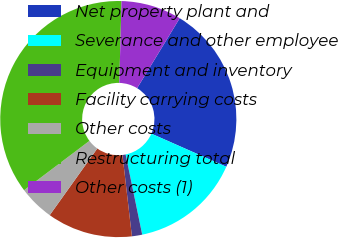<chart> <loc_0><loc_0><loc_500><loc_500><pie_chart><fcel>Net property plant and<fcel>Severance and other employee<fcel>Equipment and inventory<fcel>Facility carrying costs<fcel>Other costs<fcel>Restructuring total<fcel>Other costs (1)<nl><fcel>22.91%<fcel>15.13%<fcel>1.41%<fcel>11.7%<fcel>4.84%<fcel>35.72%<fcel>8.27%<nl></chart> 